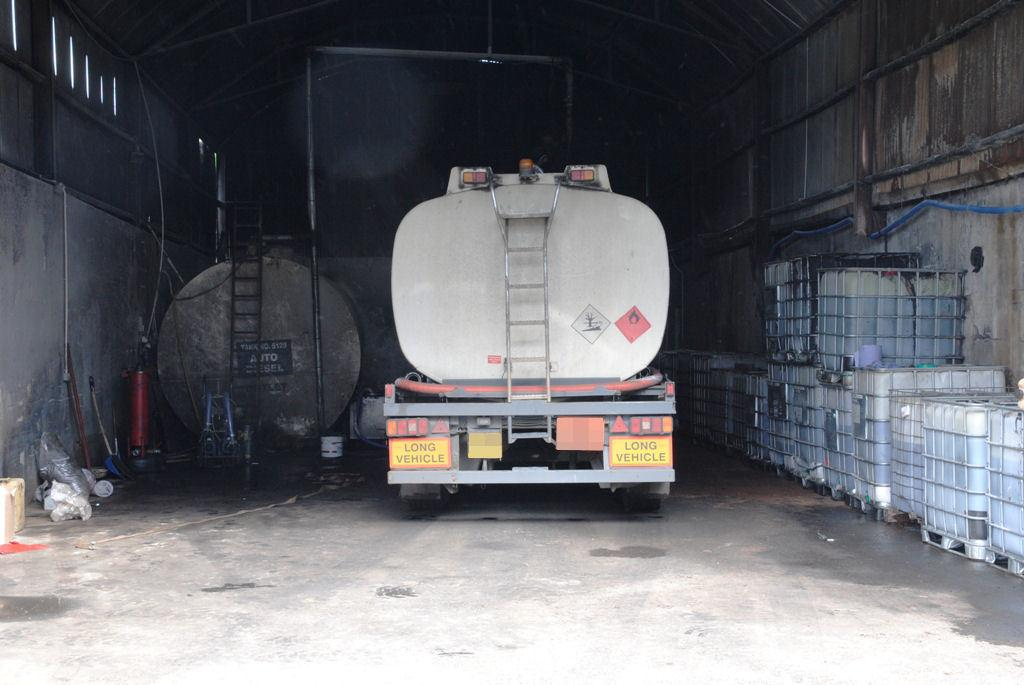What is the main subject of the image? There is a vehicle at the center of the image. What can be seen on the sides of the image? There are walls on both the left and right sides of the image. What is present on the surface in the image? There are objects placed on the surface in the image. How would you describe the background of the image? The background of the image is dark. What type of apple does the daughter prefer in the image? There is no daughter or apple present in the image. What is the daughter's favorite eggnog recipe in the image? There is no daughter or eggnog mentioned in the image. 